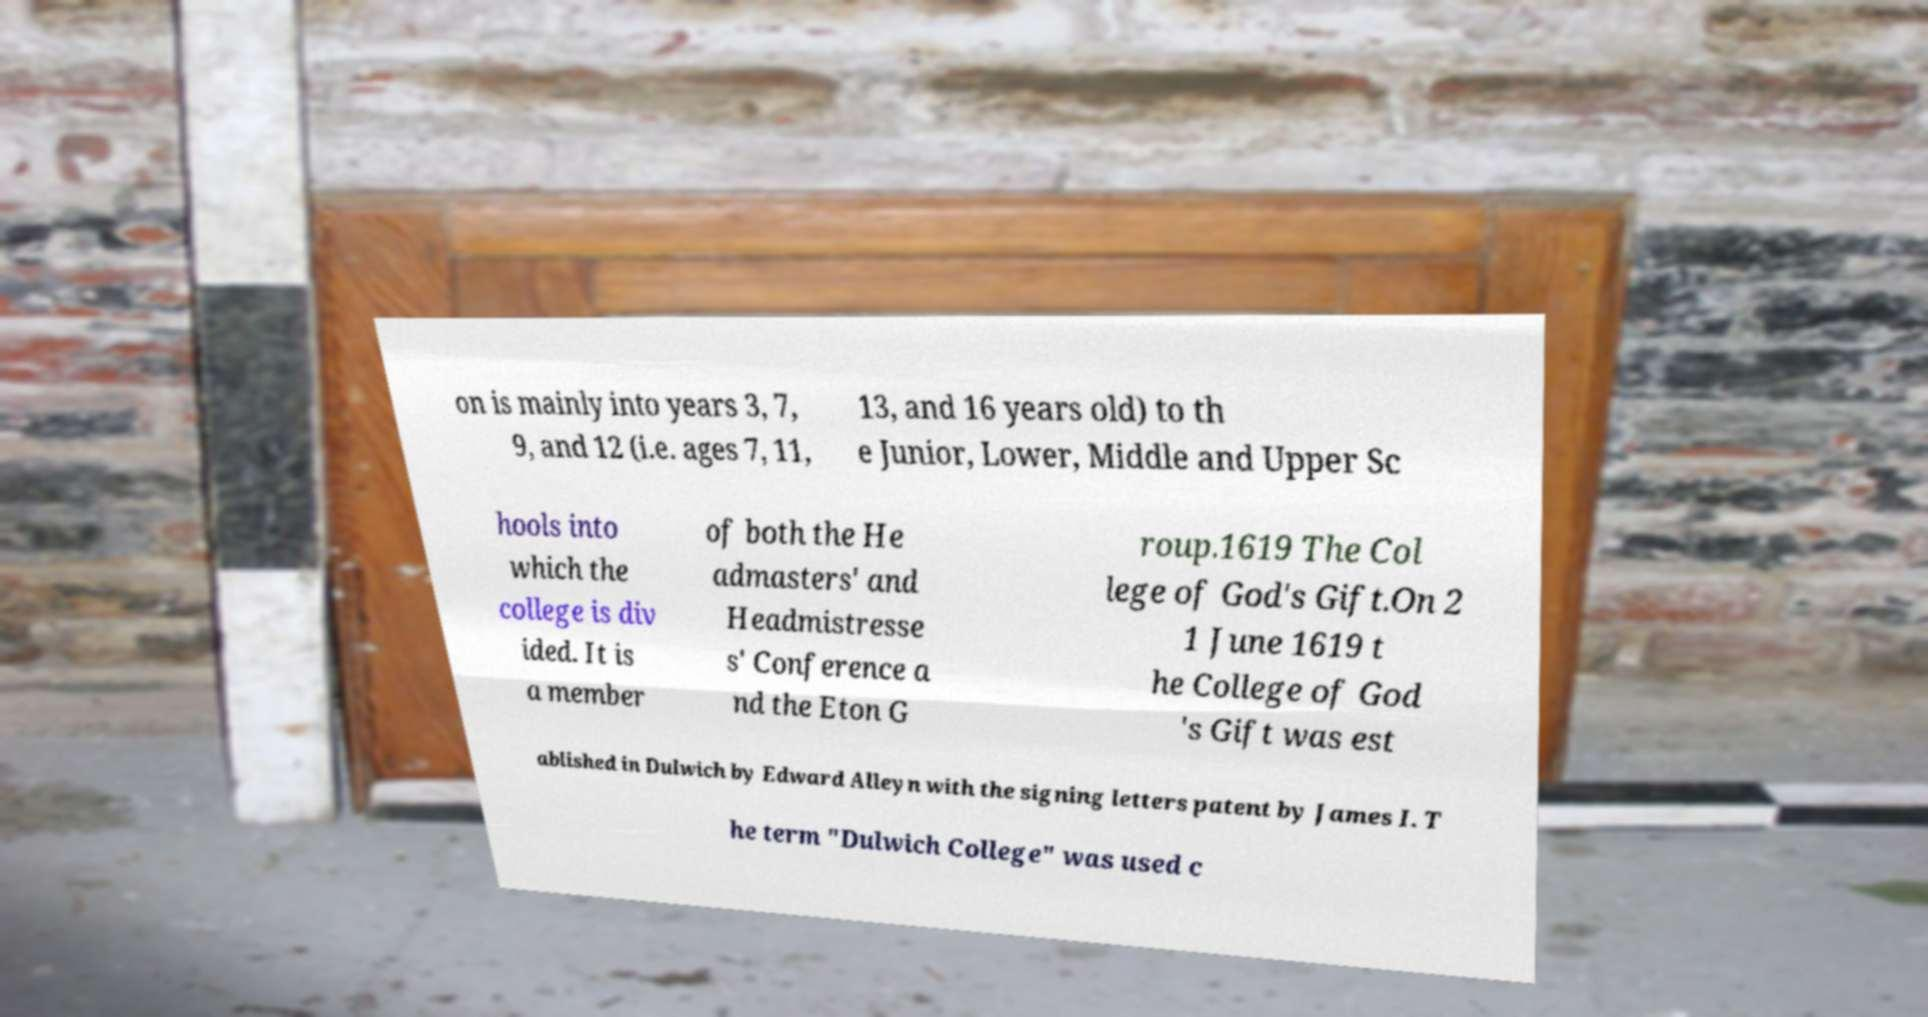Please identify and transcribe the text found in this image. on is mainly into years 3, 7, 9, and 12 (i.e. ages 7, 11, 13, and 16 years old) to th e Junior, Lower, Middle and Upper Sc hools into which the college is div ided. It is a member of both the He admasters' and Headmistresse s' Conference a nd the Eton G roup.1619 The Col lege of God's Gift.On 2 1 June 1619 t he College of God 's Gift was est ablished in Dulwich by Edward Alleyn with the signing letters patent by James I. T he term "Dulwich College" was used c 